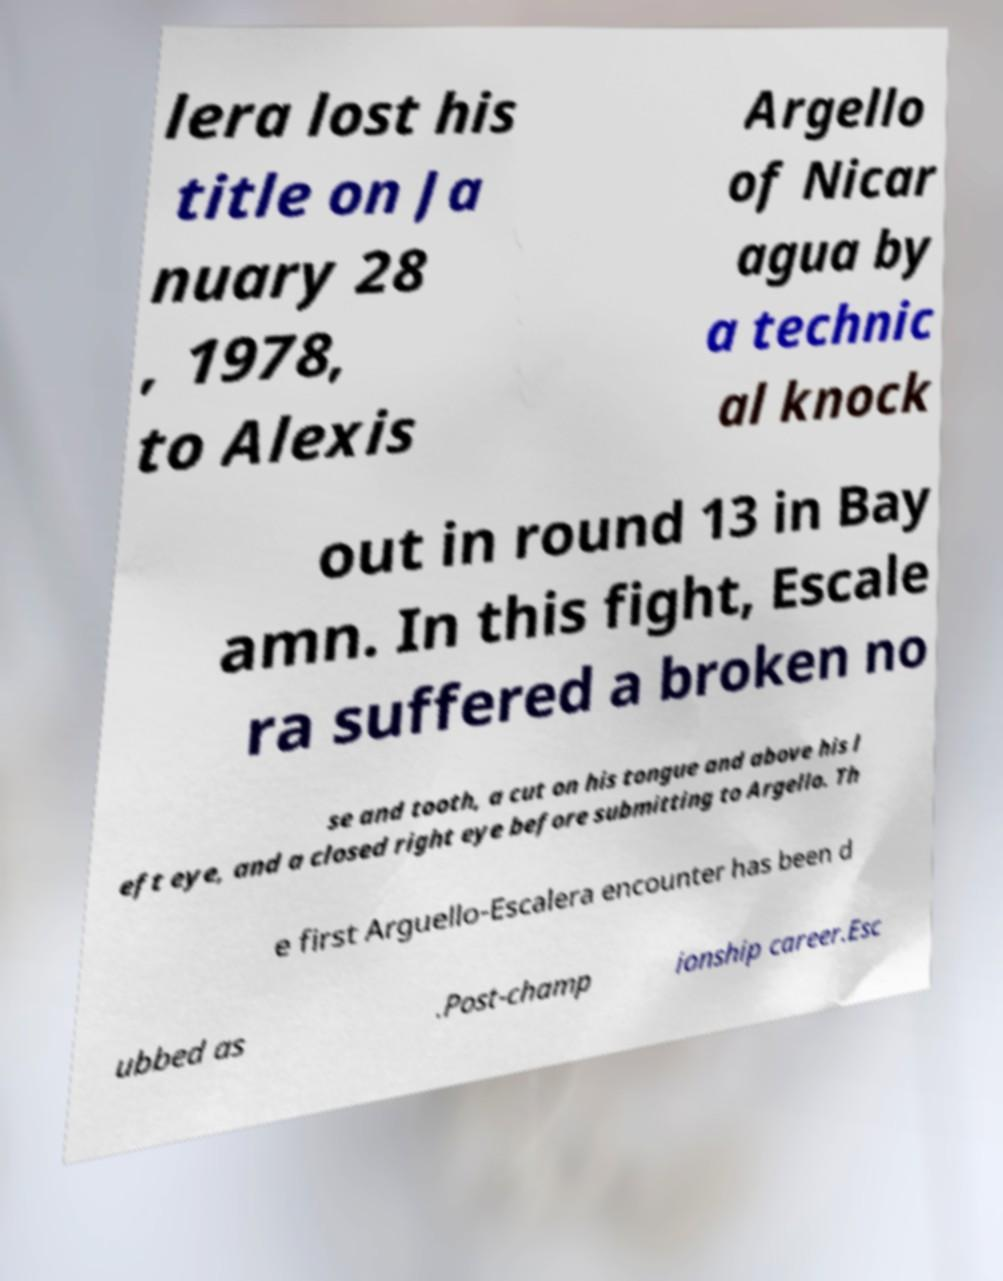Could you extract and type out the text from this image? lera lost his title on Ja nuary 28 , 1978, to Alexis Argello of Nicar agua by a technic al knock out in round 13 in Bay amn. In this fight, Escale ra suffered a broken no se and tooth, a cut on his tongue and above his l eft eye, and a closed right eye before submitting to Argello. Th e first Arguello-Escalera encounter has been d ubbed as .Post-champ ionship career.Esc 